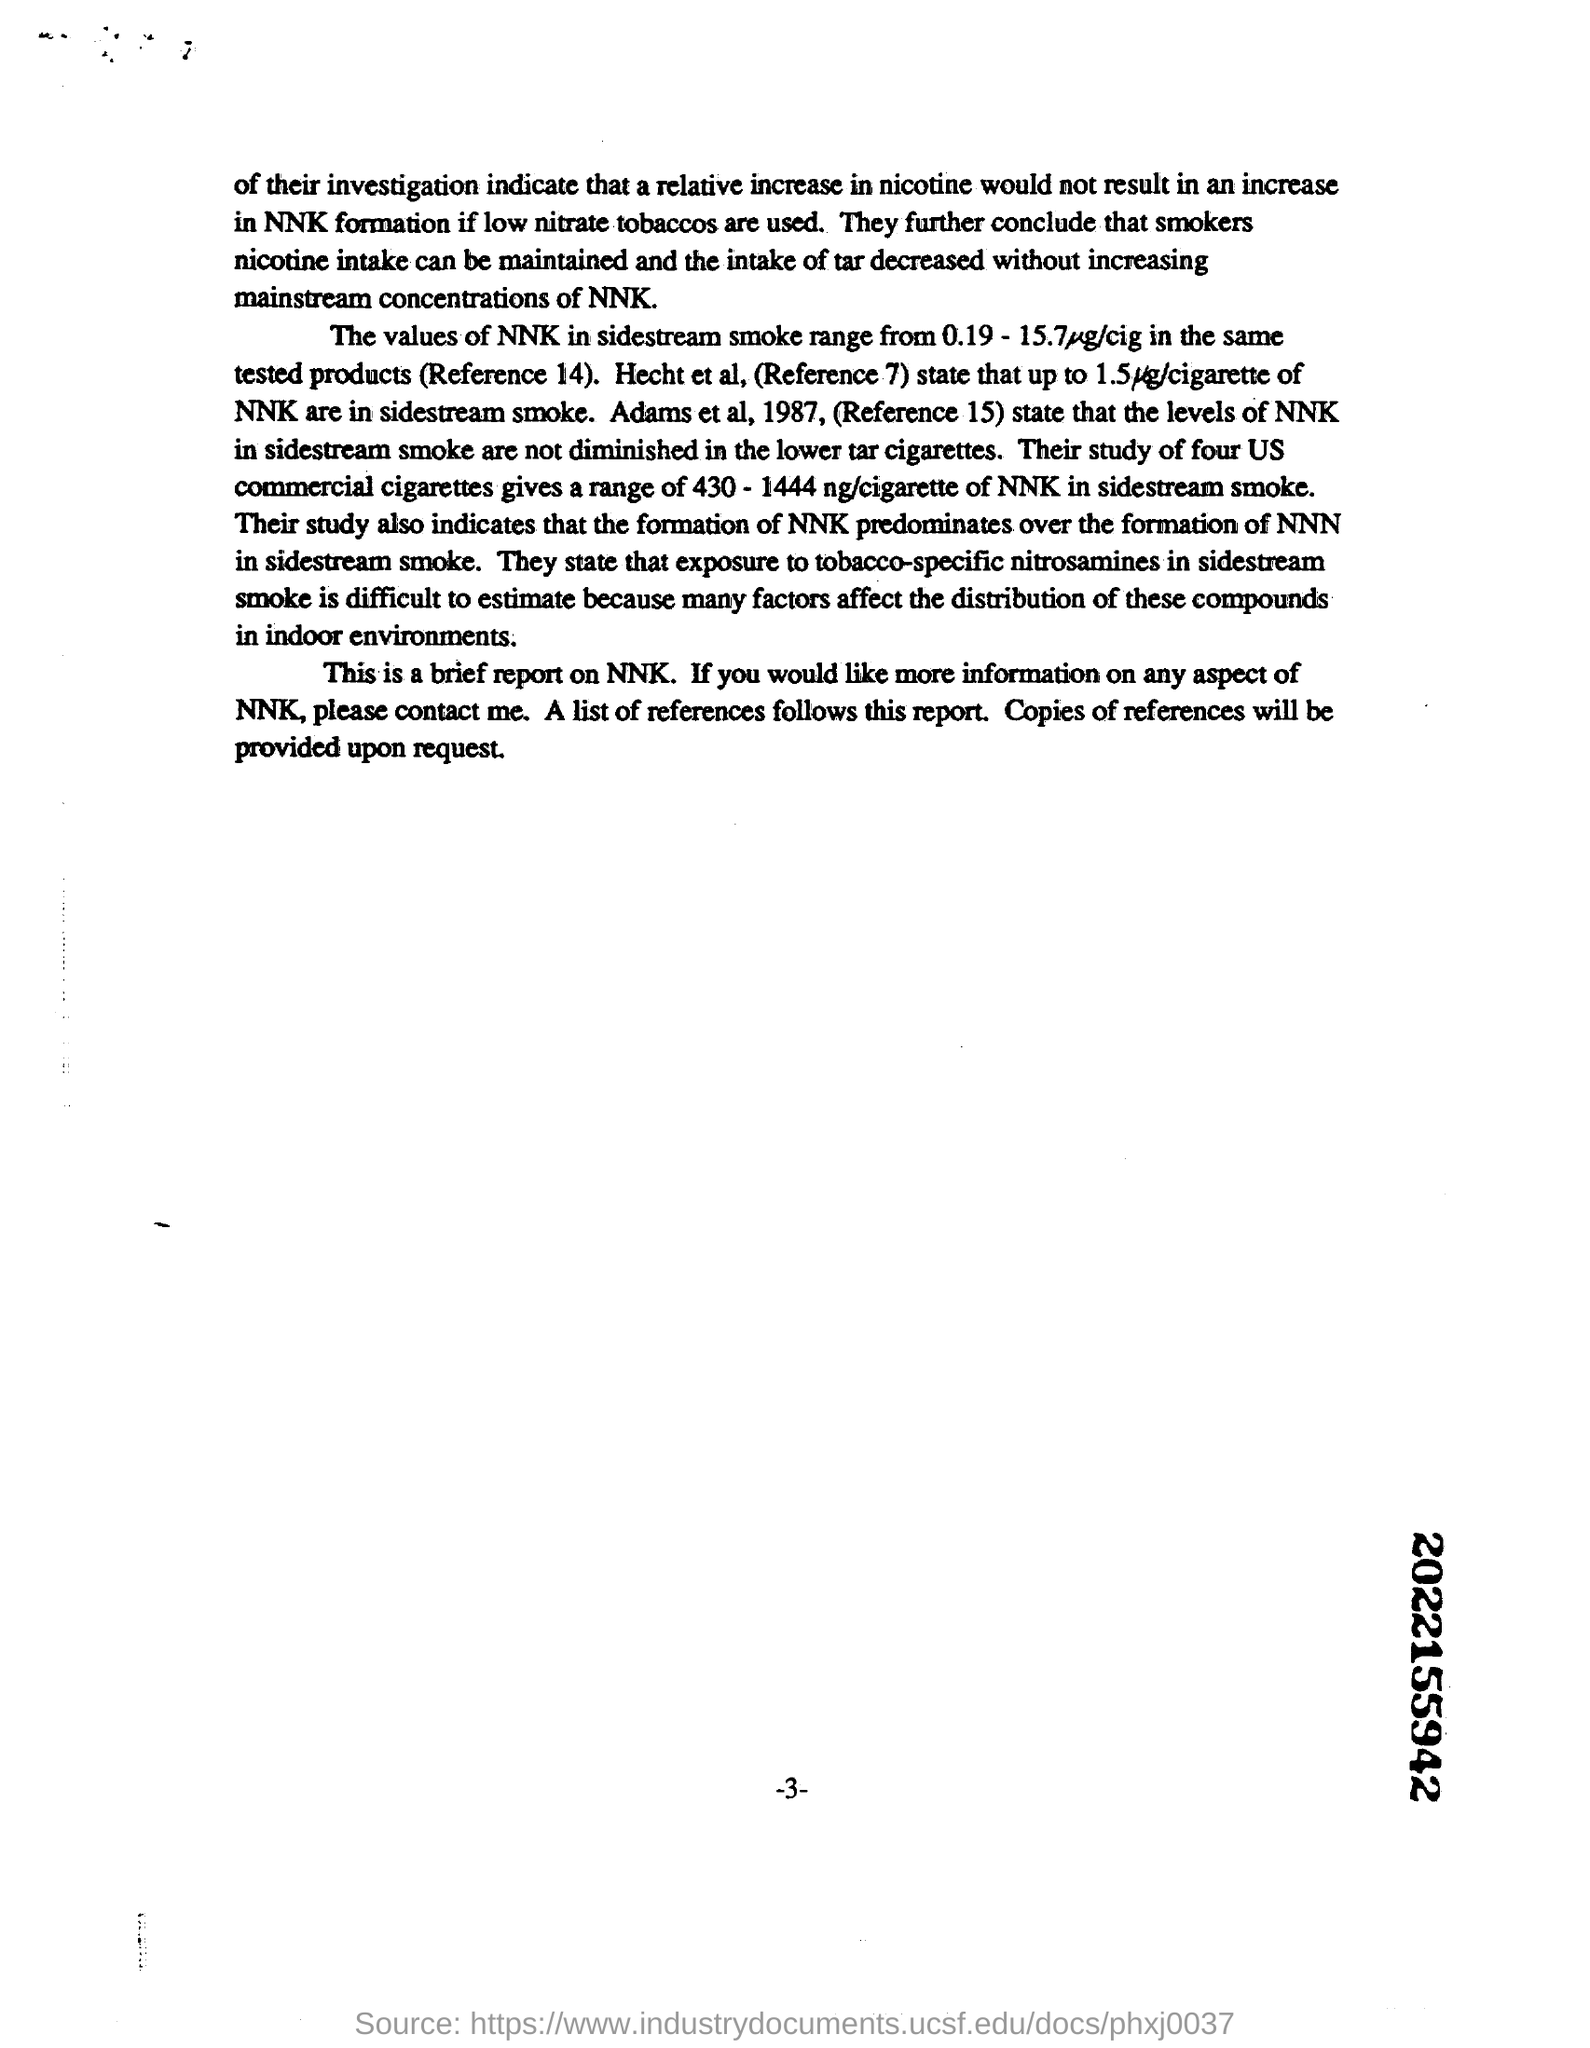What should be used to avoid increase in NNk formation?
Offer a terse response. Low nitrate tobaccos. What is the brief report on?
Offer a terse response. NNK. 